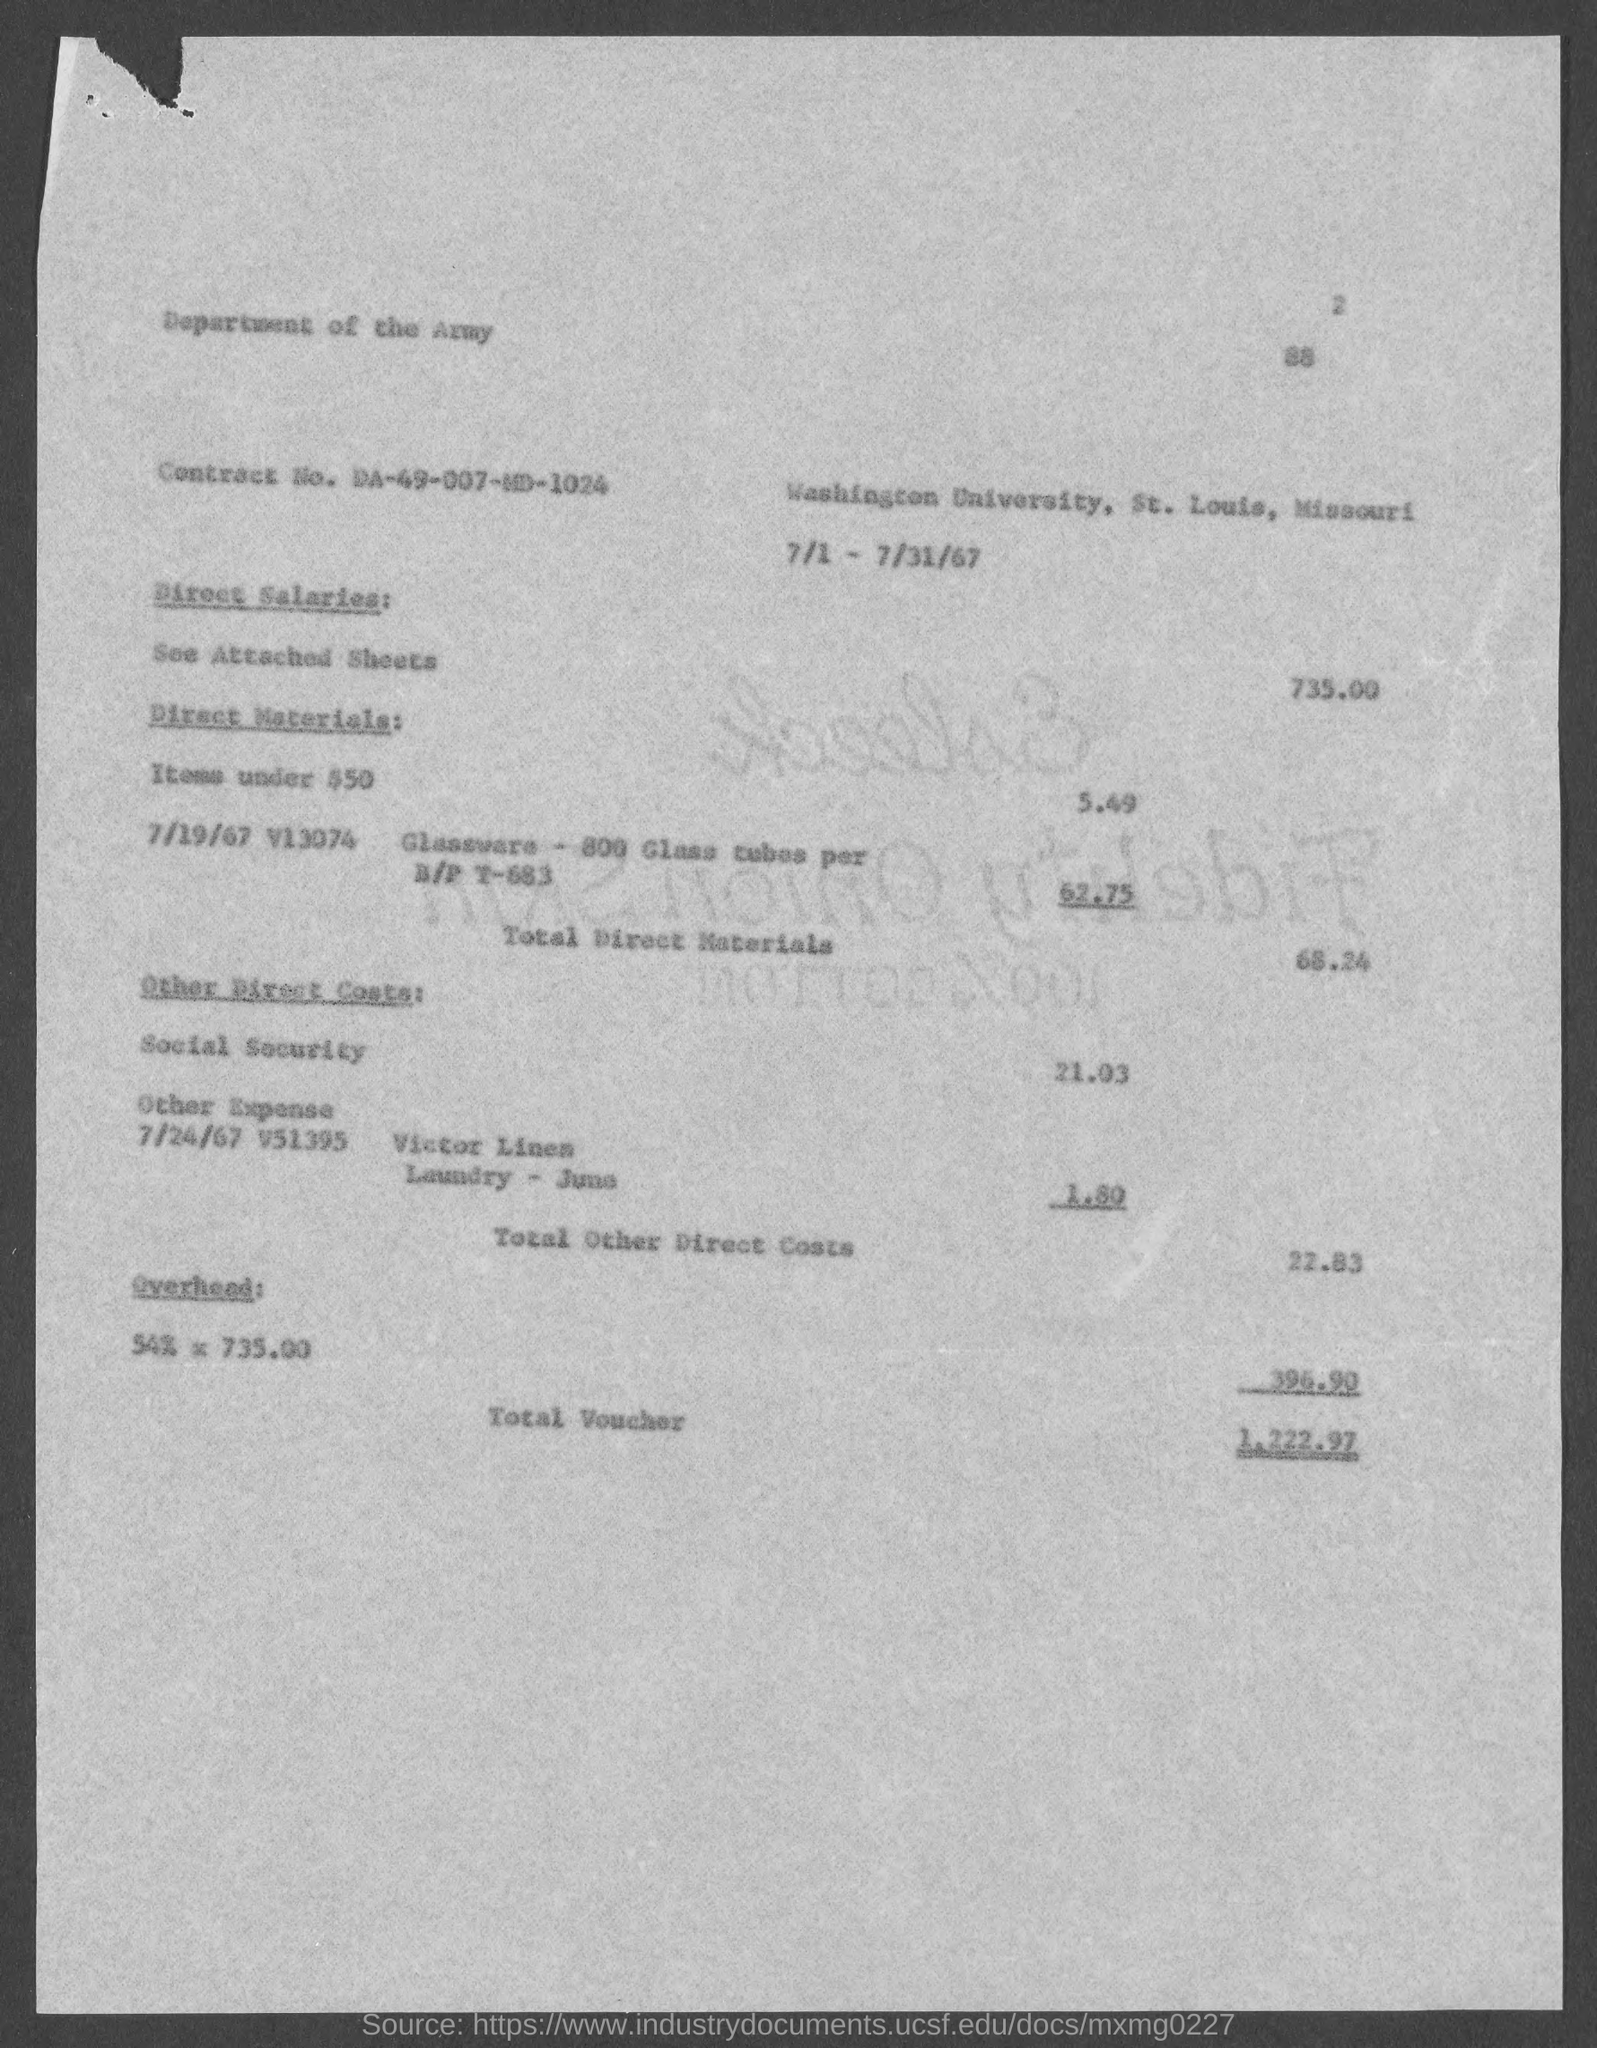Is this document contemporary or does it appear to be from a previous era, and why? This document is not contemporary. It is dated from 7/1 to 7/31/67, which suggests it is from the year 1967. The typewriter font, paper quality, and format are also indicative of documents produced in the mid-20th century. 